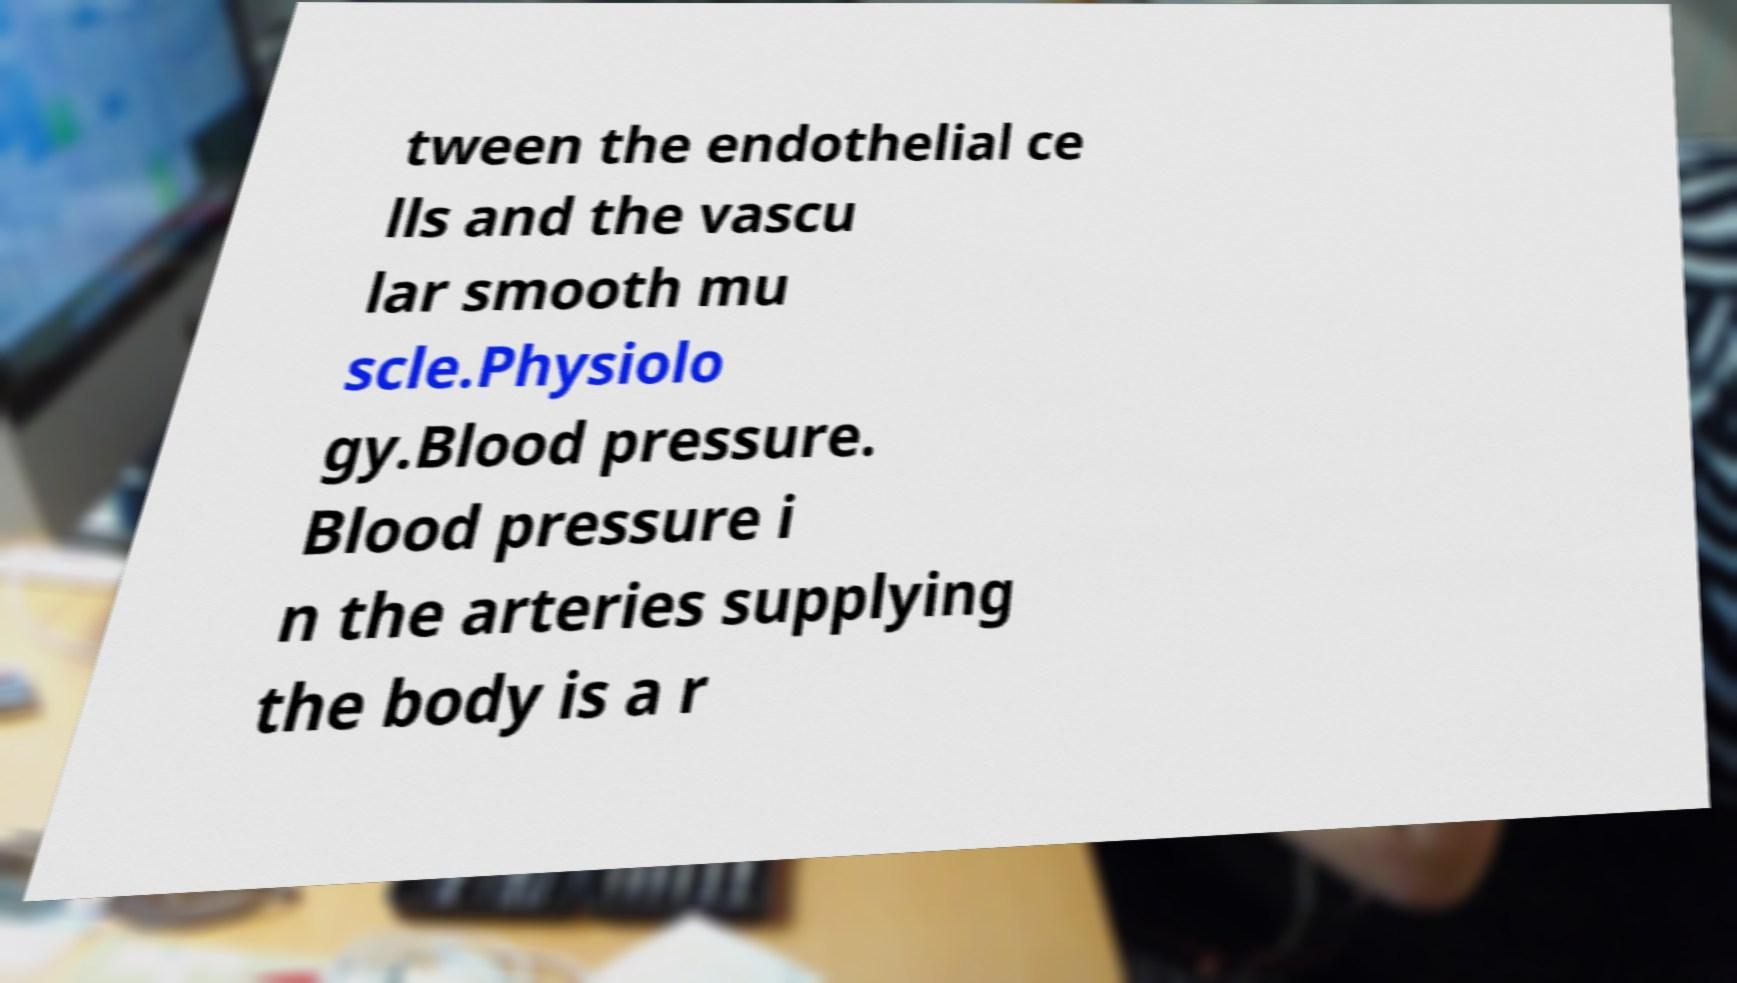Can you read and provide the text displayed in the image?This photo seems to have some interesting text. Can you extract and type it out for me? tween the endothelial ce lls and the vascu lar smooth mu scle.Physiolo gy.Blood pressure. Blood pressure i n the arteries supplying the body is a r 